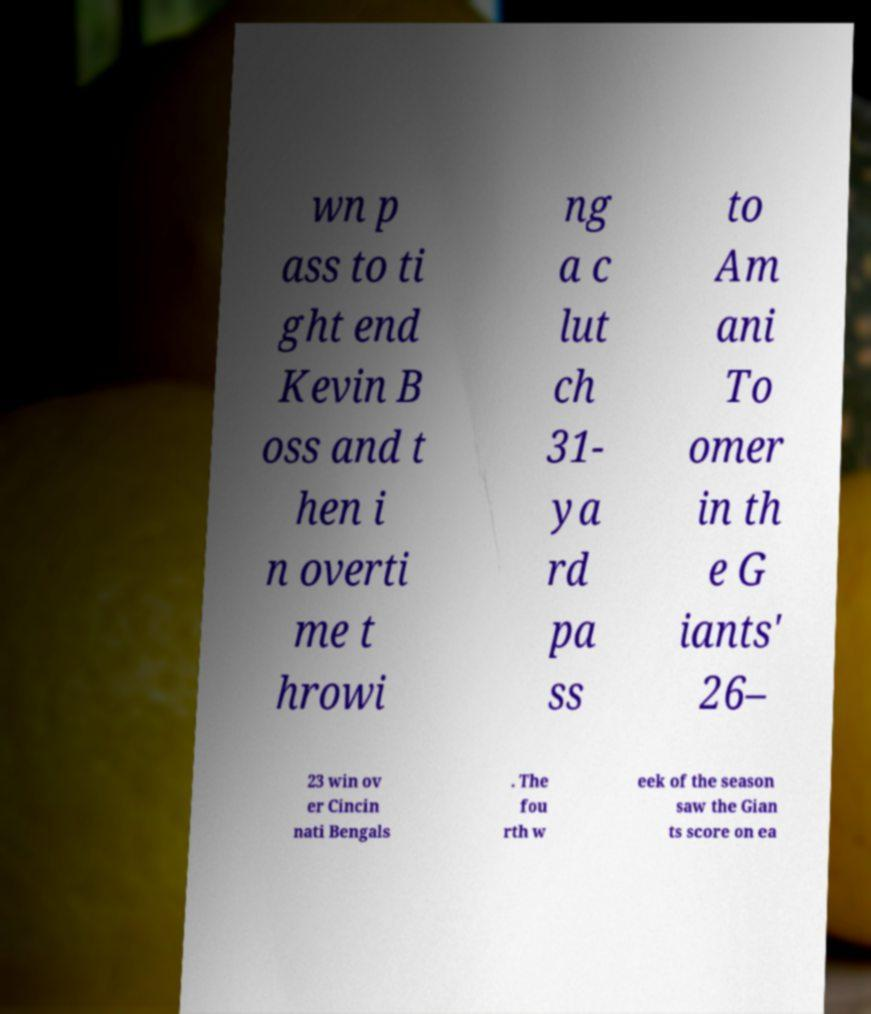I need the written content from this picture converted into text. Can you do that? wn p ass to ti ght end Kevin B oss and t hen i n overti me t hrowi ng a c lut ch 31- ya rd pa ss to Am ani To omer in th e G iants' 26– 23 win ov er Cincin nati Bengals . The fou rth w eek of the season saw the Gian ts score on ea 